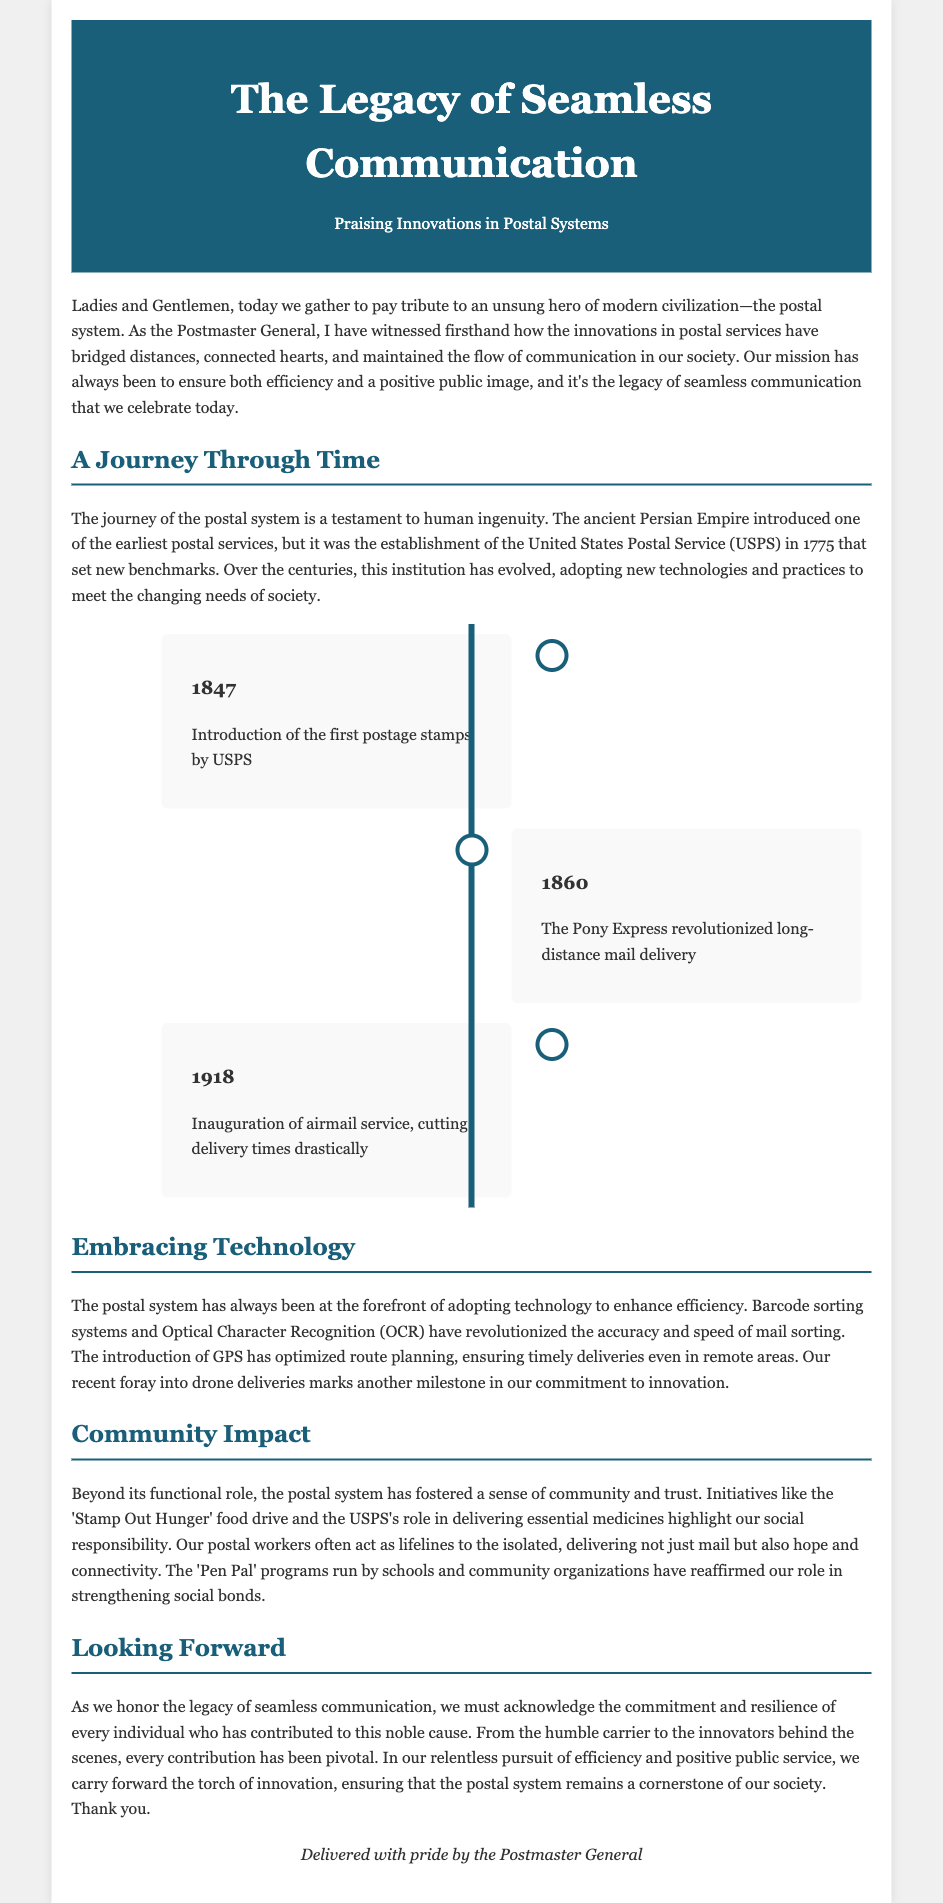What year was the USPS established? The document states that the USPS was established in 1775.
Answer: 1775 What significant milestone occurred in 1847? The document mentions the introduction of the first postage stamps by USPS in 1847.
Answer: First postage stamps What technology enhances mail sorting accuracy? The document highlights that Optical Character Recognition (OCR) enhances mail sorting accuracy.
Answer: Optical Character Recognition What program fosters social connections? The document notes that 'Pen Pal' programs run by schools and community organizations foster social connections.
Answer: 'Pen Pal' programs What year marked the beginning of airmail service? According to the document, airmail service was inaugurated in 1918.
Answer: 1918 What initiative addresses hunger? The document states that the 'Stamp Out Hunger' food drive addresses hunger.
Answer: 'Stamp Out Hunger' food drive How has the postal system advanced deliveries in remote areas? The document explains that GPS has optimized route planning for timely deliveries in remote areas.
Answer: GPS What was the purpose of the Pony Express? The document indicates that the purpose of the Pony Express was to revolutionize long-distance mail delivery.
Answer: Revolutionized long-distance mail delivery 